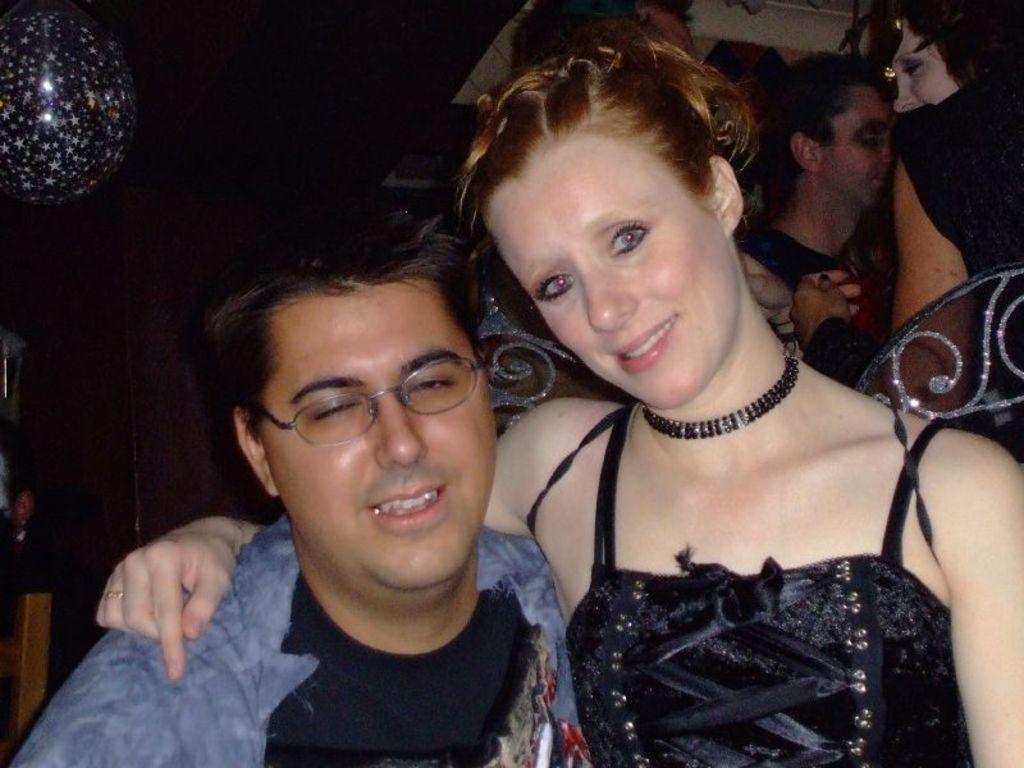In one or two sentences, can you explain what this image depicts? In this image, we can see a woman holding a man beside her. They both are smiling. In the background, there are people, balloon, few objects and dark view. 